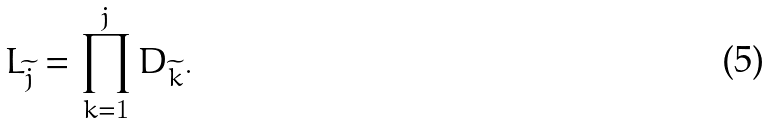<formula> <loc_0><loc_0><loc_500><loc_500>L _ { \widetilde { j } } = \prod _ { k = 1 } ^ { j } D _ { \widetilde { k } } .</formula> 